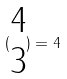Convert formula to latex. <formula><loc_0><loc_0><loc_500><loc_500>( \begin{matrix} 4 \\ 3 \end{matrix} ) = 4</formula> 